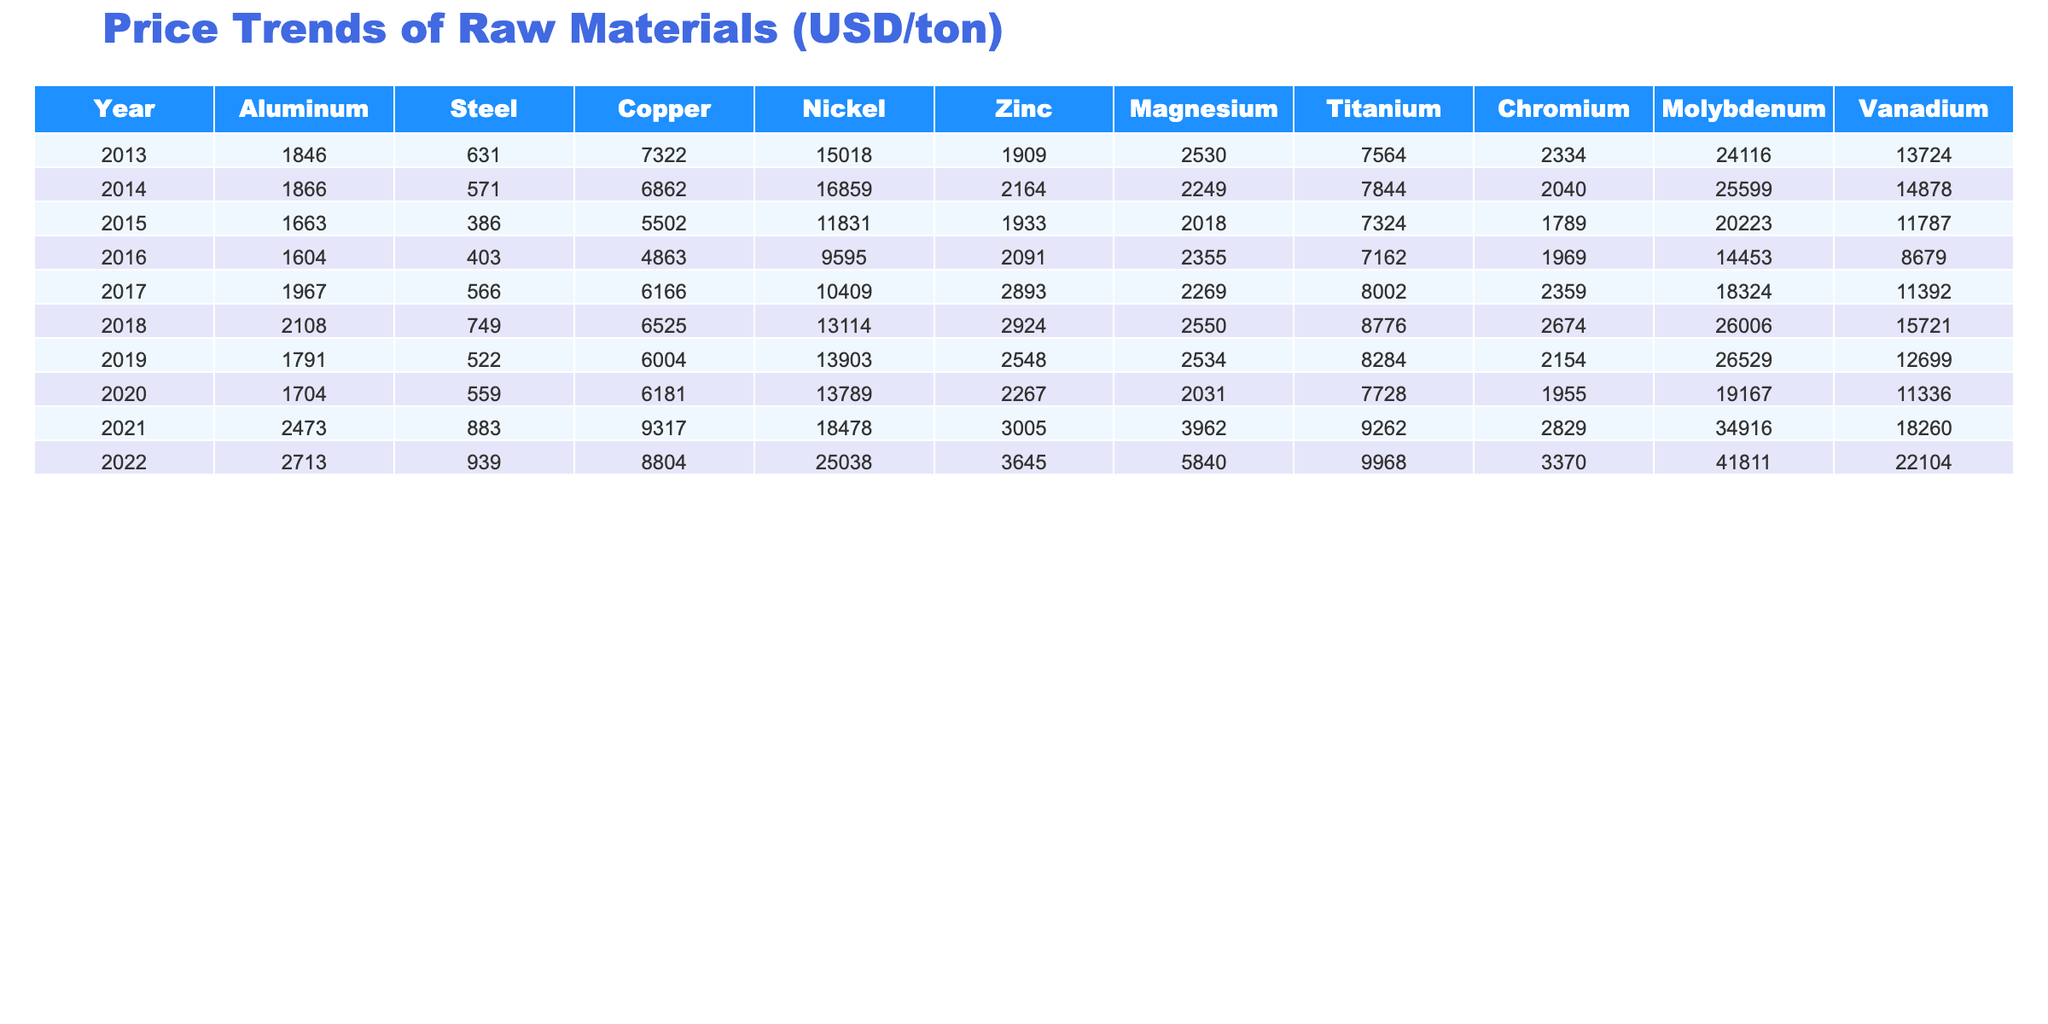What was the highest price of aluminum in 2021? Looking at the table, the price of aluminum in 2021 is noted as 2473. This is the highest value in the entire decade from 2013 to 2022 listed for aluminum.
Answer: 2473 What was the average price of copper over the past decade? To find the average price of copper, we sum the values from 2013 to 2022 which are: 7322 + 6862 + 5502 + 4863 + 6166 + 6525 + 6004 + 6181 + 9317 + 8804 = 6356. Then, we divide by the number of years (10), giving us 63560 / 10 = 6356.
Answer: 6356 Did the price of magnesium ever exceed 3500 in the given years? By inspecting the prices for magnesium from 2013 to 2022, the maximum observed price was 3962 in 2021, which is greater than 3500. Therefore, the statement is true.
Answer: Yes What was the price difference of nickel between 2013 and 2022? The price of nickel in 2013 was 15018 and in 2022 it was 25038. The difference is calculated as 25038 - 15018 = 10020. This indicates a significant increase in price over the decade.
Answer: 10020 Which year experienced the highest steel prices and what was the price? The highest price for steel is found by checking each year's value, with 939 noted as the peak in 2022. It was the only year surpassing the previous high of 883 in 2021.
Answer: 939 What is the total increase in the price of zinc from 2013 to 2022? The price of zinc in 2013 was 1909, and in 2022 it was 3645. The increase is calculated by subtracting the 2013 price from the 2022 price: 3645 - 1909 = 1736. This shows significant growth in zinc prices over the decade.
Answer: 1736 Which raw material had the most dramatic price change over the decade? Analyzing the trends, nickel had prices of 15018 in 2013 and rose to 25038 in 2022, which is an increase of 10020. This is more substantial compared to other materials, making it the raw material with the highest dramatic price change over the decade.
Answer: Nickel Was there any year when the price of aluminum fell below 1700? By examining the aluminum prices throughout the years, we see that the lowest price was 1663 in 2015, which indicates that yes, there was a year when the price fell below 1700.
Answer: Yes Calculate the average price of titanium over the last decade. To find the average price of titanium, we sum the yearly values: 7564 + 7844 + 7324 + 7162 + 8002 + 8776 + 8284 + 7728 + 9262 + 9968 = 8004. We then divide by 10 years to get an average of 80040 / 10 = 8004.
Answer: 8004 What was the steel price trend from 2013 to 2022? Observing the table, the steel prices began at 631 in 2013, dropped to a low of 386 in 2015, slowly increased again, with a steady climb to 939 by 2022, indicating a general upward trend after some fluctuation.
Answer: Overall upward trend 